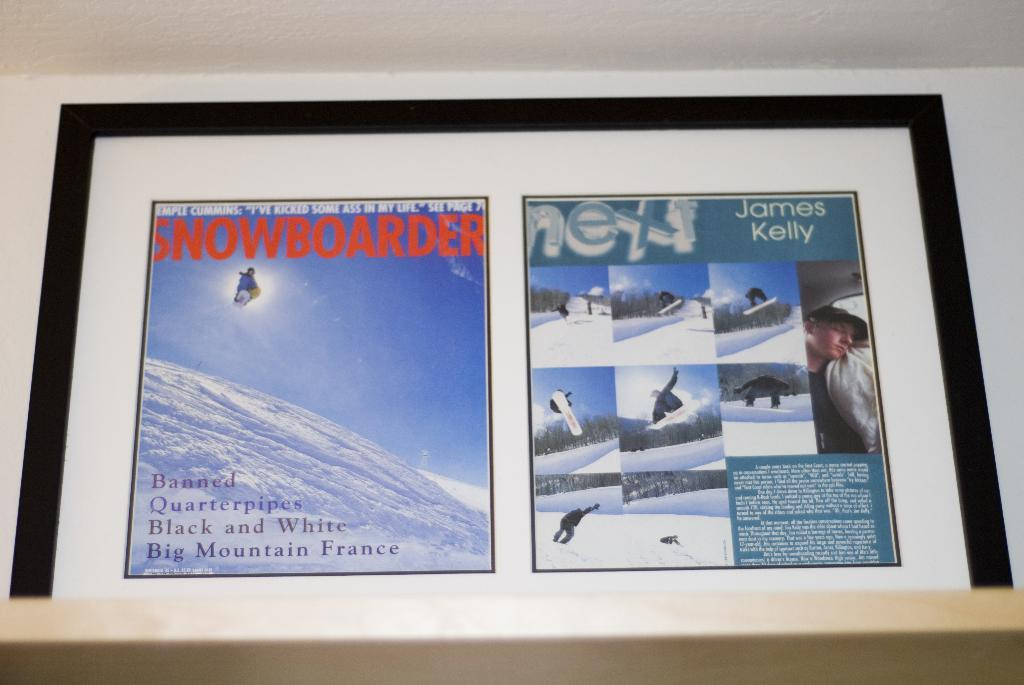What is located at the bottom of the image? There is a table at the bottom of the image. What can be seen in the middle of the image? There is a frame attached to the wall in the middle of the image. What is inside the frame? The frame contains text and images of persons. Can you see a squirrel driving a lift in the image? No, there is no squirrel or lift present in the image. The image features a table at the bottom and a frame with text and images of persons in the middle. 